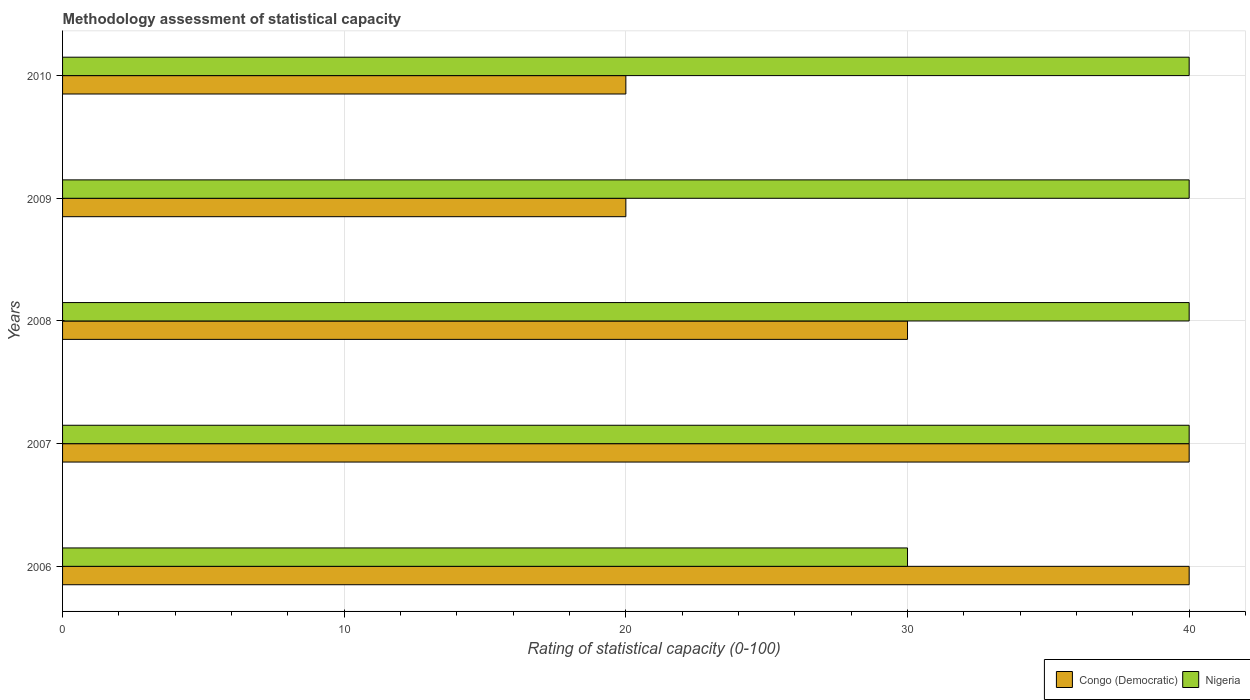How many bars are there on the 1st tick from the top?
Provide a succinct answer. 2. How many bars are there on the 3rd tick from the bottom?
Provide a short and direct response. 2. What is the label of the 3rd group of bars from the top?
Keep it short and to the point. 2008. What is the rating of statistical capacity in Congo (Democratic) in 2009?
Make the answer very short. 20. Across all years, what is the maximum rating of statistical capacity in Congo (Democratic)?
Your response must be concise. 40. Across all years, what is the minimum rating of statistical capacity in Nigeria?
Provide a succinct answer. 30. In which year was the rating of statistical capacity in Nigeria minimum?
Your answer should be compact. 2006. What is the total rating of statistical capacity in Congo (Democratic) in the graph?
Keep it short and to the point. 150. What is the difference between the rating of statistical capacity in Congo (Democratic) in 2008 and that in 2009?
Make the answer very short. 10. What is the average rating of statistical capacity in Congo (Democratic) per year?
Your response must be concise. 30. In how many years, is the rating of statistical capacity in Congo (Democratic) greater than 4 ?
Keep it short and to the point. 5. What is the ratio of the rating of statistical capacity in Congo (Democratic) in 2006 to that in 2009?
Offer a very short reply. 2. Is the rating of statistical capacity in Congo (Democratic) in 2006 less than that in 2009?
Ensure brevity in your answer.  No. Is the difference between the rating of statistical capacity in Nigeria in 2007 and 2009 greater than the difference between the rating of statistical capacity in Congo (Democratic) in 2007 and 2009?
Give a very brief answer. No. What is the difference between the highest and the lowest rating of statistical capacity in Nigeria?
Your answer should be very brief. 10. Is the sum of the rating of statistical capacity in Congo (Democratic) in 2008 and 2010 greater than the maximum rating of statistical capacity in Nigeria across all years?
Offer a terse response. Yes. What does the 1st bar from the top in 2007 represents?
Your answer should be very brief. Nigeria. What does the 2nd bar from the bottom in 2010 represents?
Give a very brief answer. Nigeria. How many bars are there?
Your answer should be very brief. 10. What is the difference between two consecutive major ticks on the X-axis?
Provide a succinct answer. 10. Does the graph contain grids?
Ensure brevity in your answer.  Yes. Where does the legend appear in the graph?
Provide a succinct answer. Bottom right. What is the title of the graph?
Provide a succinct answer. Methodology assessment of statistical capacity. What is the label or title of the X-axis?
Ensure brevity in your answer.  Rating of statistical capacity (0-100). What is the label or title of the Y-axis?
Provide a short and direct response. Years. What is the Rating of statistical capacity (0-100) of Nigeria in 2008?
Give a very brief answer. 40. What is the Rating of statistical capacity (0-100) of Congo (Democratic) in 2009?
Offer a terse response. 20. What is the Rating of statistical capacity (0-100) of Nigeria in 2009?
Make the answer very short. 40. Across all years, what is the maximum Rating of statistical capacity (0-100) of Nigeria?
Give a very brief answer. 40. Across all years, what is the minimum Rating of statistical capacity (0-100) of Nigeria?
Give a very brief answer. 30. What is the total Rating of statistical capacity (0-100) of Congo (Democratic) in the graph?
Give a very brief answer. 150. What is the total Rating of statistical capacity (0-100) of Nigeria in the graph?
Provide a succinct answer. 190. What is the difference between the Rating of statistical capacity (0-100) of Nigeria in 2006 and that in 2007?
Make the answer very short. -10. What is the difference between the Rating of statistical capacity (0-100) in Nigeria in 2006 and that in 2009?
Your answer should be very brief. -10. What is the difference between the Rating of statistical capacity (0-100) in Congo (Democratic) in 2006 and that in 2010?
Give a very brief answer. 20. What is the difference between the Rating of statistical capacity (0-100) of Nigeria in 2006 and that in 2010?
Ensure brevity in your answer.  -10. What is the difference between the Rating of statistical capacity (0-100) in Nigeria in 2007 and that in 2010?
Give a very brief answer. 0. What is the difference between the Rating of statistical capacity (0-100) in Congo (Democratic) in 2009 and that in 2010?
Your answer should be compact. 0. What is the difference between the Rating of statistical capacity (0-100) in Nigeria in 2009 and that in 2010?
Offer a very short reply. 0. What is the difference between the Rating of statistical capacity (0-100) in Congo (Democratic) in 2006 and the Rating of statistical capacity (0-100) in Nigeria in 2008?
Provide a short and direct response. 0. What is the difference between the Rating of statistical capacity (0-100) in Congo (Democratic) in 2006 and the Rating of statistical capacity (0-100) in Nigeria in 2009?
Offer a terse response. 0. What is the difference between the Rating of statistical capacity (0-100) of Congo (Democratic) in 2006 and the Rating of statistical capacity (0-100) of Nigeria in 2010?
Make the answer very short. 0. What is the difference between the Rating of statistical capacity (0-100) in Congo (Democratic) in 2008 and the Rating of statistical capacity (0-100) in Nigeria in 2009?
Provide a short and direct response. -10. What is the difference between the Rating of statistical capacity (0-100) in Congo (Democratic) in 2008 and the Rating of statistical capacity (0-100) in Nigeria in 2010?
Provide a short and direct response. -10. What is the average Rating of statistical capacity (0-100) of Congo (Democratic) per year?
Give a very brief answer. 30. What is the average Rating of statistical capacity (0-100) of Nigeria per year?
Your answer should be very brief. 38. In the year 2006, what is the difference between the Rating of statistical capacity (0-100) of Congo (Democratic) and Rating of statistical capacity (0-100) of Nigeria?
Keep it short and to the point. 10. In the year 2007, what is the difference between the Rating of statistical capacity (0-100) of Congo (Democratic) and Rating of statistical capacity (0-100) of Nigeria?
Your answer should be compact. 0. What is the ratio of the Rating of statistical capacity (0-100) of Congo (Democratic) in 2006 to that in 2007?
Give a very brief answer. 1. What is the ratio of the Rating of statistical capacity (0-100) of Congo (Democratic) in 2006 to that in 2010?
Keep it short and to the point. 2. What is the ratio of the Rating of statistical capacity (0-100) in Nigeria in 2007 to that in 2008?
Provide a succinct answer. 1. What is the ratio of the Rating of statistical capacity (0-100) in Nigeria in 2007 to that in 2009?
Offer a very short reply. 1. What is the ratio of the Rating of statistical capacity (0-100) of Congo (Democratic) in 2008 to that in 2009?
Offer a very short reply. 1.5. What is the ratio of the Rating of statistical capacity (0-100) in Nigeria in 2008 to that in 2009?
Offer a very short reply. 1. What is the ratio of the Rating of statistical capacity (0-100) of Congo (Democratic) in 2009 to that in 2010?
Offer a terse response. 1. What is the ratio of the Rating of statistical capacity (0-100) in Nigeria in 2009 to that in 2010?
Your response must be concise. 1. What is the difference between the highest and the second highest Rating of statistical capacity (0-100) of Nigeria?
Offer a terse response. 0. What is the difference between the highest and the lowest Rating of statistical capacity (0-100) in Congo (Democratic)?
Offer a terse response. 20. What is the difference between the highest and the lowest Rating of statistical capacity (0-100) of Nigeria?
Offer a terse response. 10. 